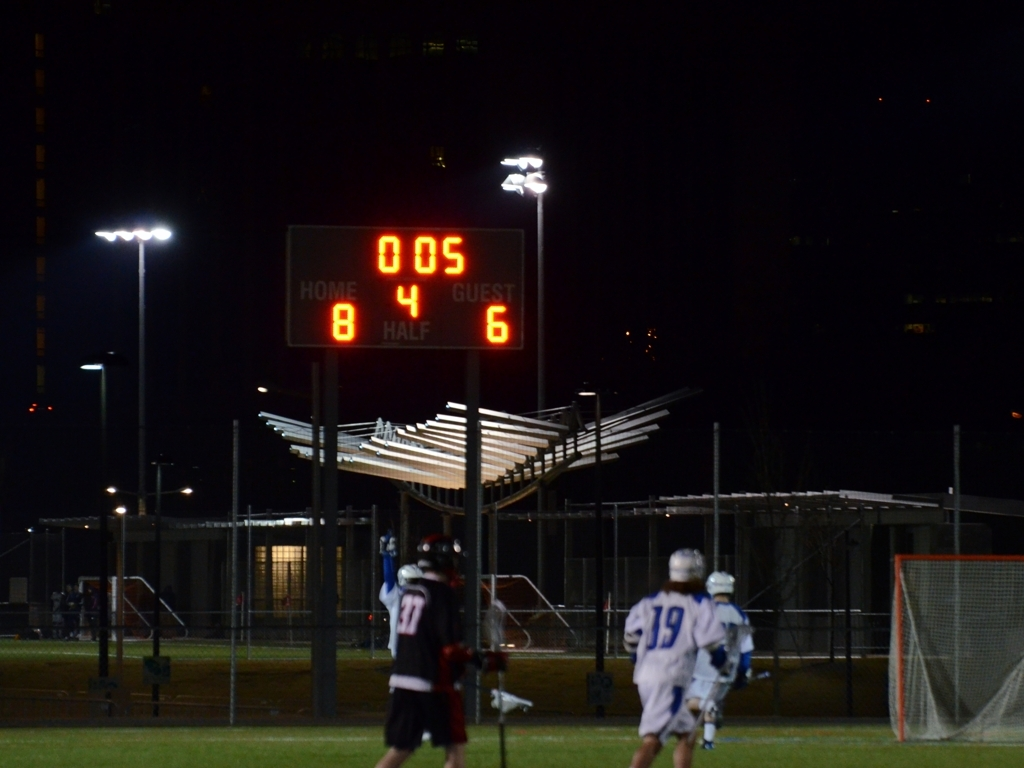Is the quality of this image unacceptable? While the focus in this image is not sharp, making details a bit difficult to discern, it may still be considered acceptable for certain contexts where the emphasis is on capturing the atmosphere of the scene rather than fine details. 